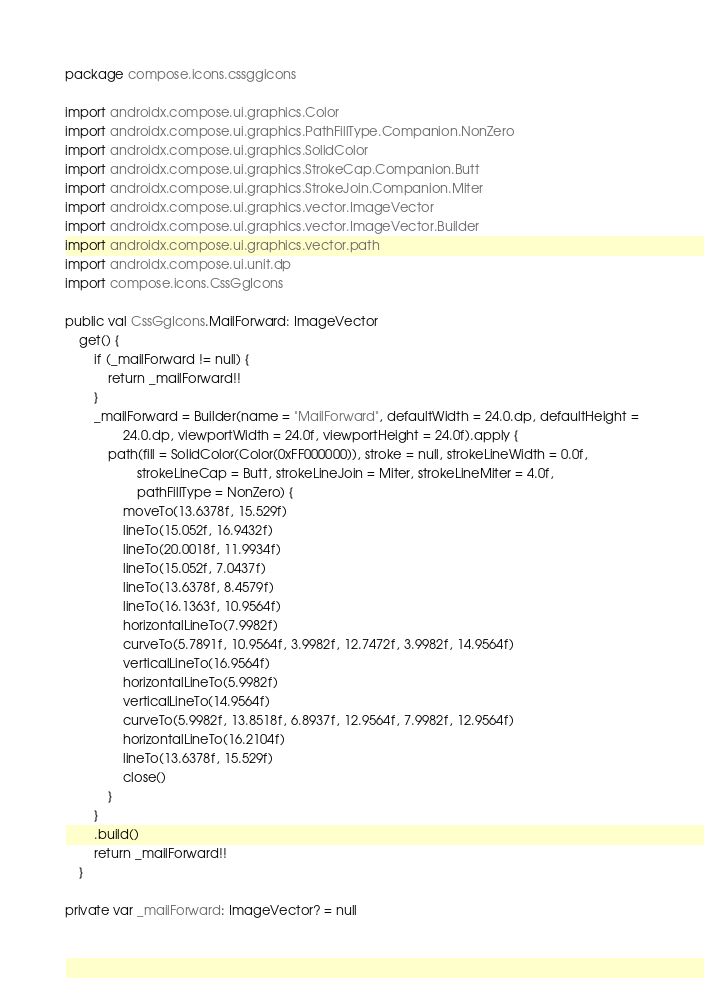Convert code to text. <code><loc_0><loc_0><loc_500><loc_500><_Kotlin_>package compose.icons.cssggicons

import androidx.compose.ui.graphics.Color
import androidx.compose.ui.graphics.PathFillType.Companion.NonZero
import androidx.compose.ui.graphics.SolidColor
import androidx.compose.ui.graphics.StrokeCap.Companion.Butt
import androidx.compose.ui.graphics.StrokeJoin.Companion.Miter
import androidx.compose.ui.graphics.vector.ImageVector
import androidx.compose.ui.graphics.vector.ImageVector.Builder
import androidx.compose.ui.graphics.vector.path
import androidx.compose.ui.unit.dp
import compose.icons.CssGgIcons

public val CssGgIcons.MailForward: ImageVector
    get() {
        if (_mailForward != null) {
            return _mailForward!!
        }
        _mailForward = Builder(name = "MailForward", defaultWidth = 24.0.dp, defaultHeight =
                24.0.dp, viewportWidth = 24.0f, viewportHeight = 24.0f).apply {
            path(fill = SolidColor(Color(0xFF000000)), stroke = null, strokeLineWidth = 0.0f,
                    strokeLineCap = Butt, strokeLineJoin = Miter, strokeLineMiter = 4.0f,
                    pathFillType = NonZero) {
                moveTo(13.6378f, 15.529f)
                lineTo(15.052f, 16.9432f)
                lineTo(20.0018f, 11.9934f)
                lineTo(15.052f, 7.0437f)
                lineTo(13.6378f, 8.4579f)
                lineTo(16.1363f, 10.9564f)
                horizontalLineTo(7.9982f)
                curveTo(5.7891f, 10.9564f, 3.9982f, 12.7472f, 3.9982f, 14.9564f)
                verticalLineTo(16.9564f)
                horizontalLineTo(5.9982f)
                verticalLineTo(14.9564f)
                curveTo(5.9982f, 13.8518f, 6.8937f, 12.9564f, 7.9982f, 12.9564f)
                horizontalLineTo(16.2104f)
                lineTo(13.6378f, 15.529f)
                close()
            }
        }
        .build()
        return _mailForward!!
    }

private var _mailForward: ImageVector? = null
</code> 